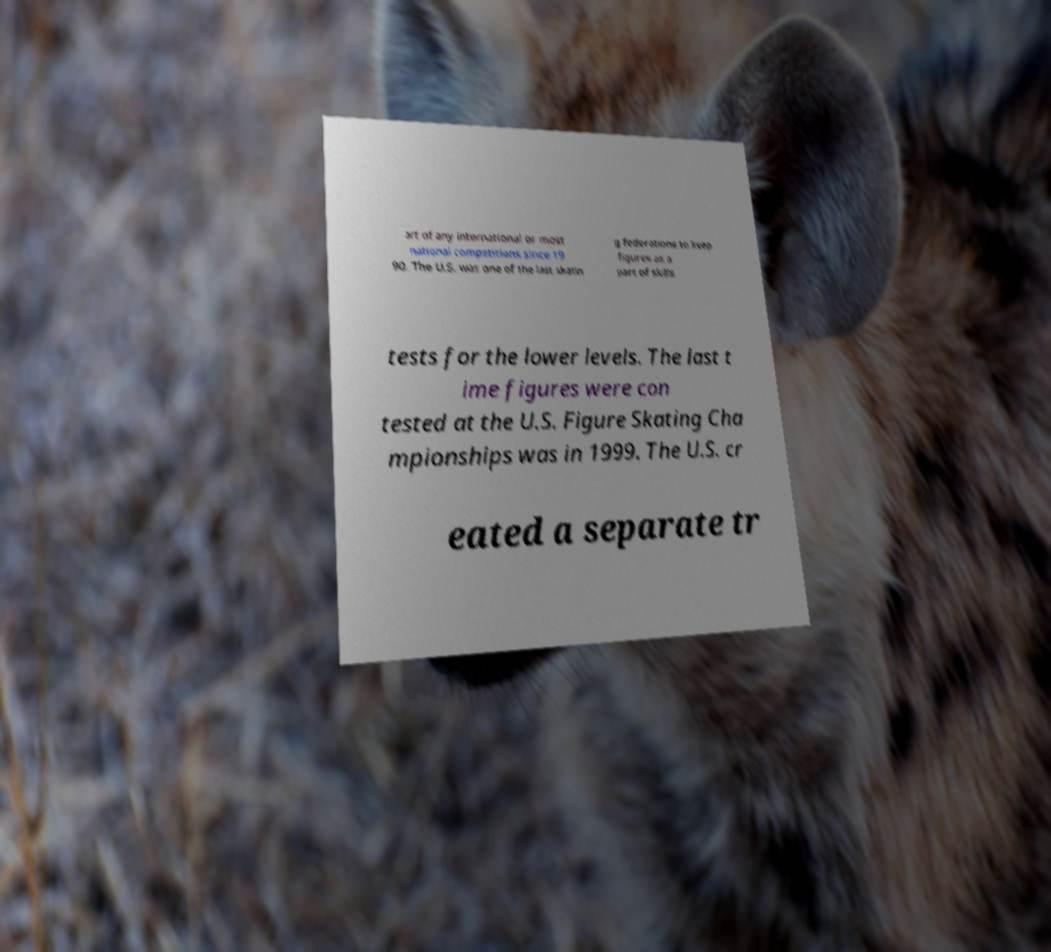There's text embedded in this image that I need extracted. Can you transcribe it verbatim? art of any international or most national competitions since 19 90. The U.S. was one of the last skatin g federations to keep figures as a part of skills tests for the lower levels. The last t ime figures were con tested at the U.S. Figure Skating Cha mpionships was in 1999. The U.S. cr eated a separate tr 